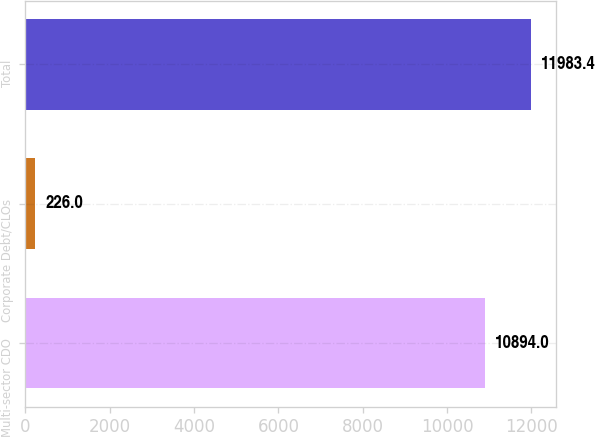<chart> <loc_0><loc_0><loc_500><loc_500><bar_chart><fcel>Multi-sector CDO<fcel>Corporate Debt/CLOs<fcel>Total<nl><fcel>10894<fcel>226<fcel>11983.4<nl></chart> 